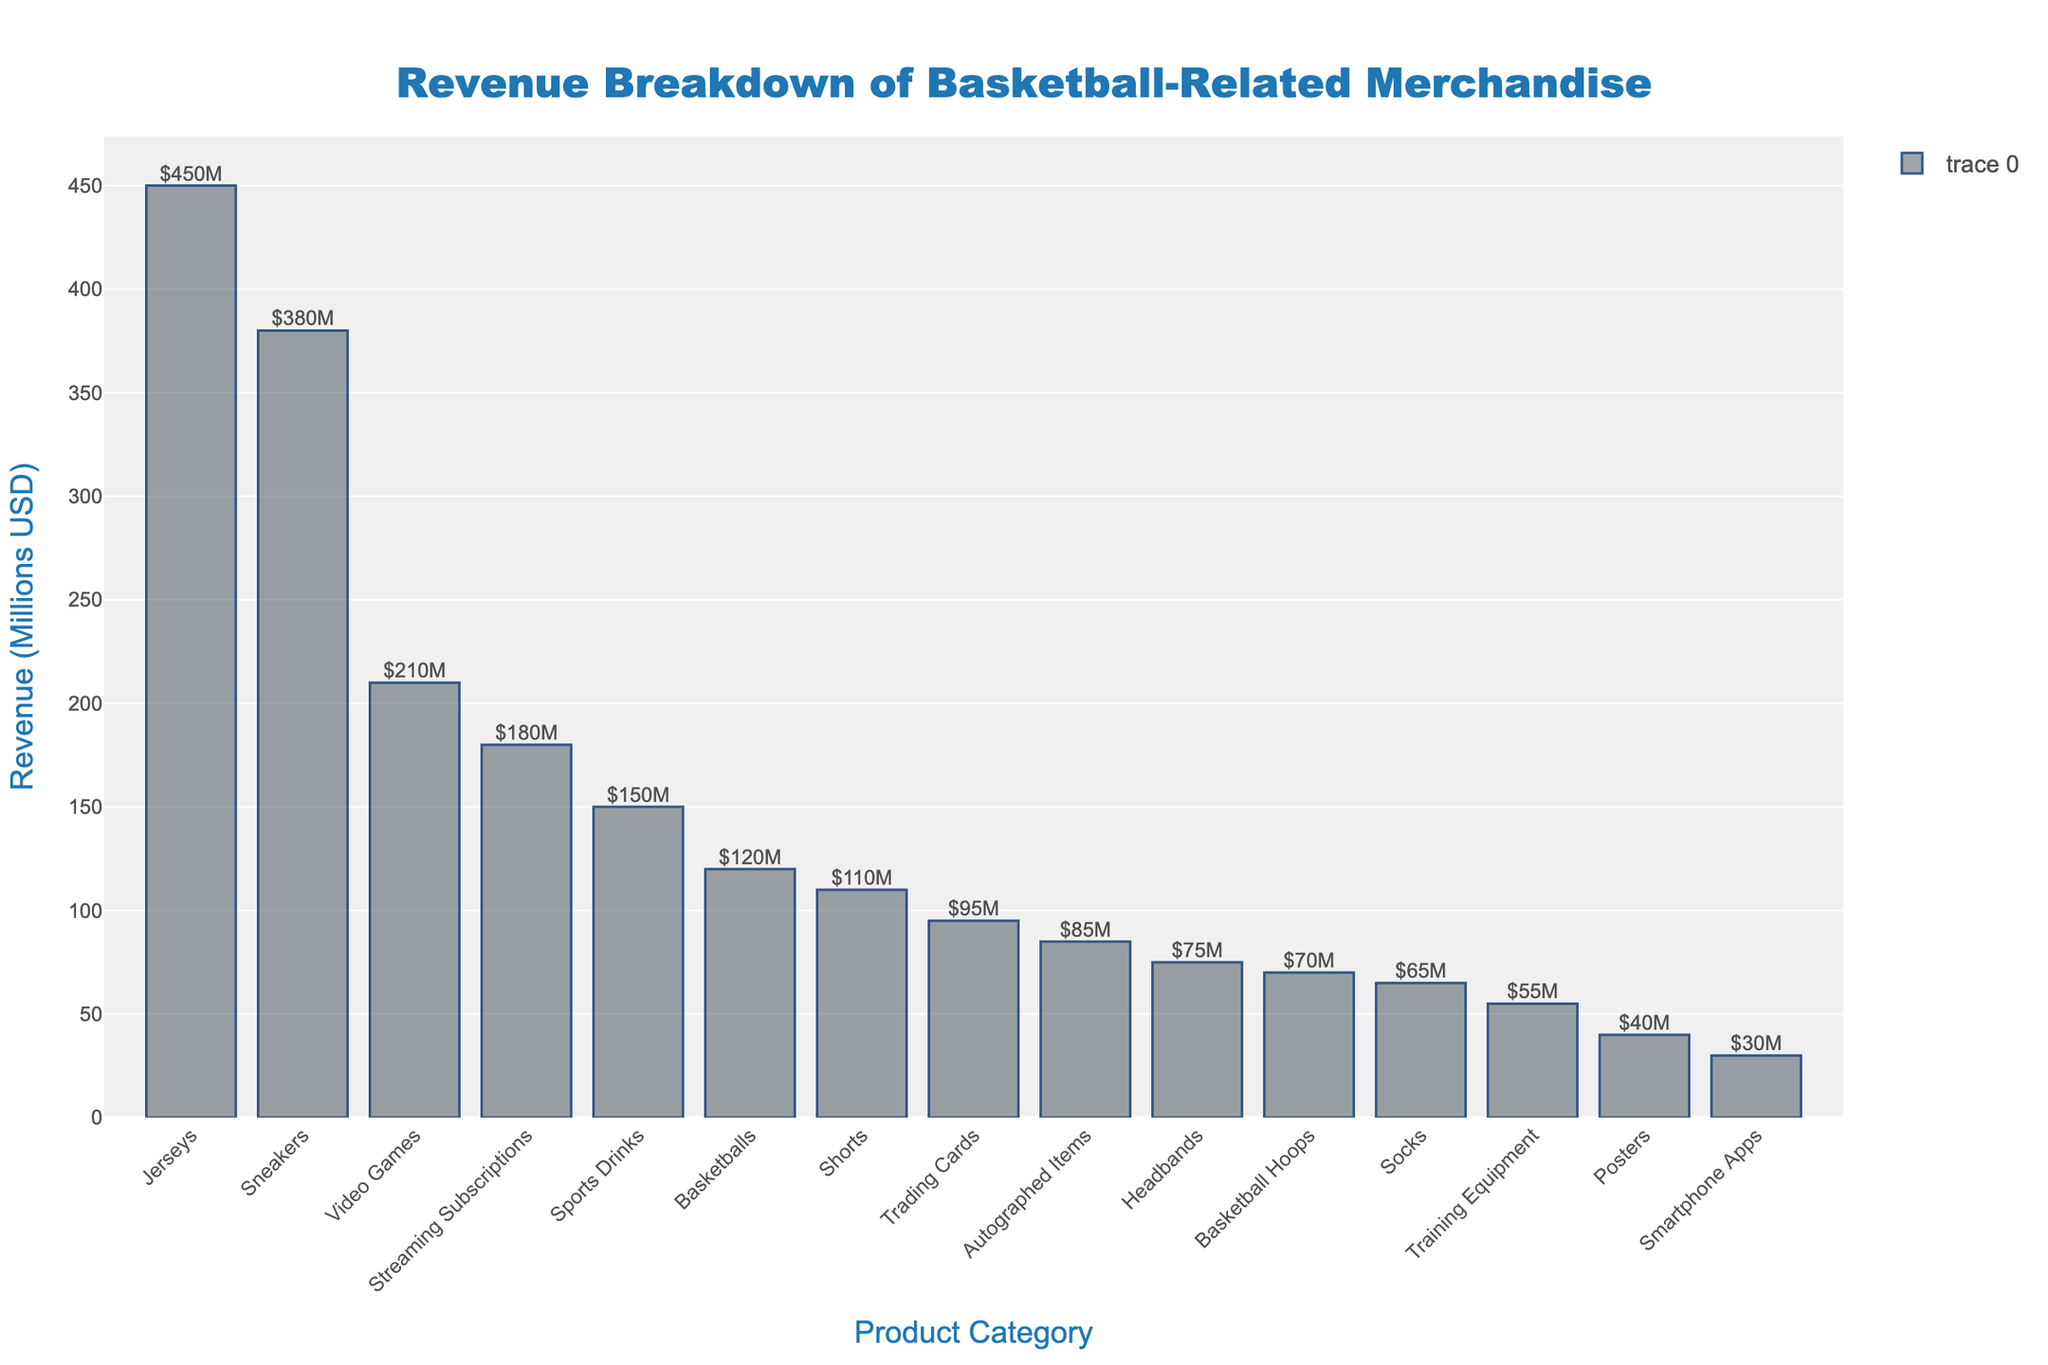Which category generated the highest revenue? The height of the bars represents revenue. The tallest bar corresponds to the 'Jerseys' category with $450M.
Answer: Jerseys How much more revenue did Jerseys generate compared to Sneakers? The revenue for Jerseys is $450M and for Sneakers is $380M. The difference is $450M - $380M = $70M.
Answer: $70M What is the total revenue generated by Headbands, Socks, and Posters combined? Sum of revenues: Headbands ($75M) + Socks ($65M) + Posters ($40M) = $180M.
Answer: $180M Which category has the lowest revenue? The shortest bar represents the 'Smartphone Apps' category with $30M.
Answer: Smartphone Apps Is the revenue from Streaming Subscriptions more than from Basketballs and Shorts combined? Revenue from Streaming Subscriptions is $180M. Revenue from Basketballs is $120M, and from Shorts is $110M. Combined, they total $120M + $110M = $230M, which is more than $180M.
Answer: No What is the average revenue of the top three categories? Top three categories are Jerseys ($450M), Sneakers ($380M), and Streaming Subscriptions ($180M). Average = ($450M + $380M + $180M) / 3 = $336.67M.
Answer: $336.67M How much revenue is generated by categories related to apparel (Jerseys, Headbands, Shorts, Socks)? Sum of revenues: Jerseys ($450M) + Headbands ($75M) + Shorts ($110M) + Socks ($65M) = $700M.
Answer: $700M Arrange Video Games, Sneakers, and Sports Drinks in descending order of revenue. The revenues are Video Games ($210M), Sneakers ($380M), and Sports Drinks ($150M). Arranged in descending order: Sneakers, Video Games, Sports Drinks.
Answer: Sneakers, Video Games, Sports Drinks What is the revenue difference between the highest and the lowest-earning categories? The highest revenue is from Jerseys ($450M), and the lowest is from Smartphone Apps ($30M). Difference = $450M - $30M = $420M.
Answer: $420M What percentage of the total revenue is generated by Autographed Items? Total revenue sum all categories: $450M + $380M + $120M + $75M + $110M + $65M + $95M + $210M + $40M + $85M + $150M + $70M + $55M + $30M + $180M = $2115M. Percentage = ($85M / $2115M) * 100 ≈ 4.02%.
Answer: 4.02% 